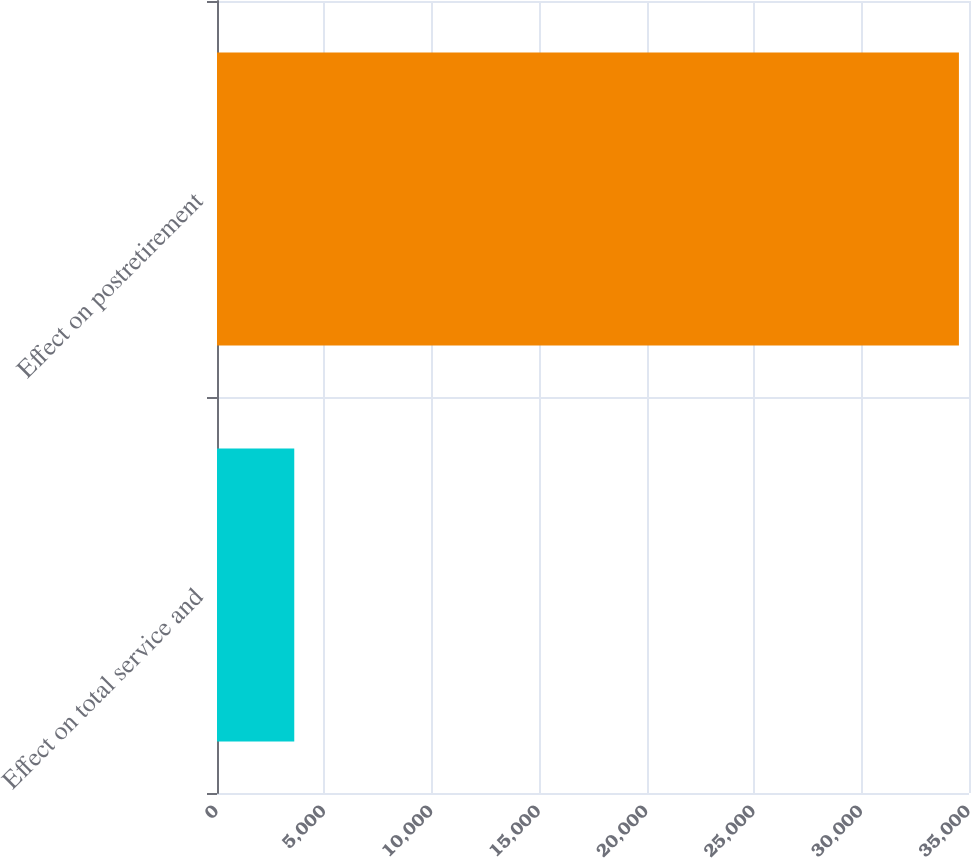Convert chart. <chart><loc_0><loc_0><loc_500><loc_500><bar_chart><fcel>Effect on total service and<fcel>Effect on postretirement<nl><fcel>3596<fcel>34531<nl></chart> 